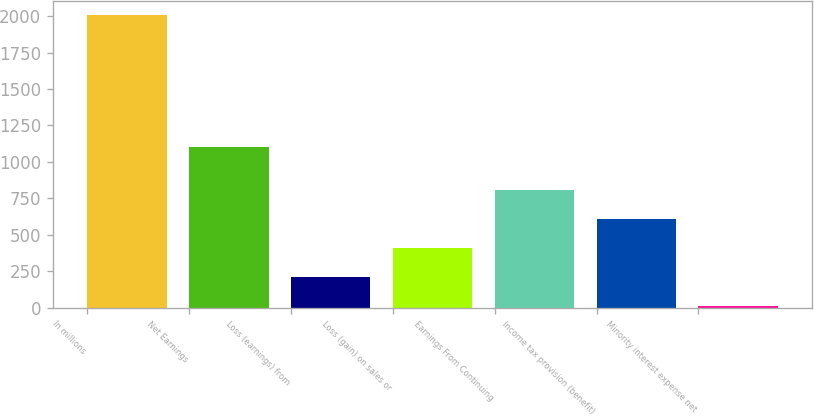Convert chart. <chart><loc_0><loc_0><loc_500><loc_500><bar_chart><fcel>In millions<fcel>Net Earnings<fcel>Loss (earnings) from<fcel>Loss (gain) on sales or<fcel>Earnings From Continuing<fcel>Income tax provision (benefit)<fcel>Minority interest expense net<nl><fcel>2005<fcel>1100<fcel>208.6<fcel>408.2<fcel>807.4<fcel>607.8<fcel>9<nl></chart> 